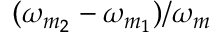Convert formula to latex. <formula><loc_0><loc_0><loc_500><loc_500>( \omega _ { m _ { 2 } } - \omega _ { m _ { 1 } } ) / \omega _ { m }</formula> 